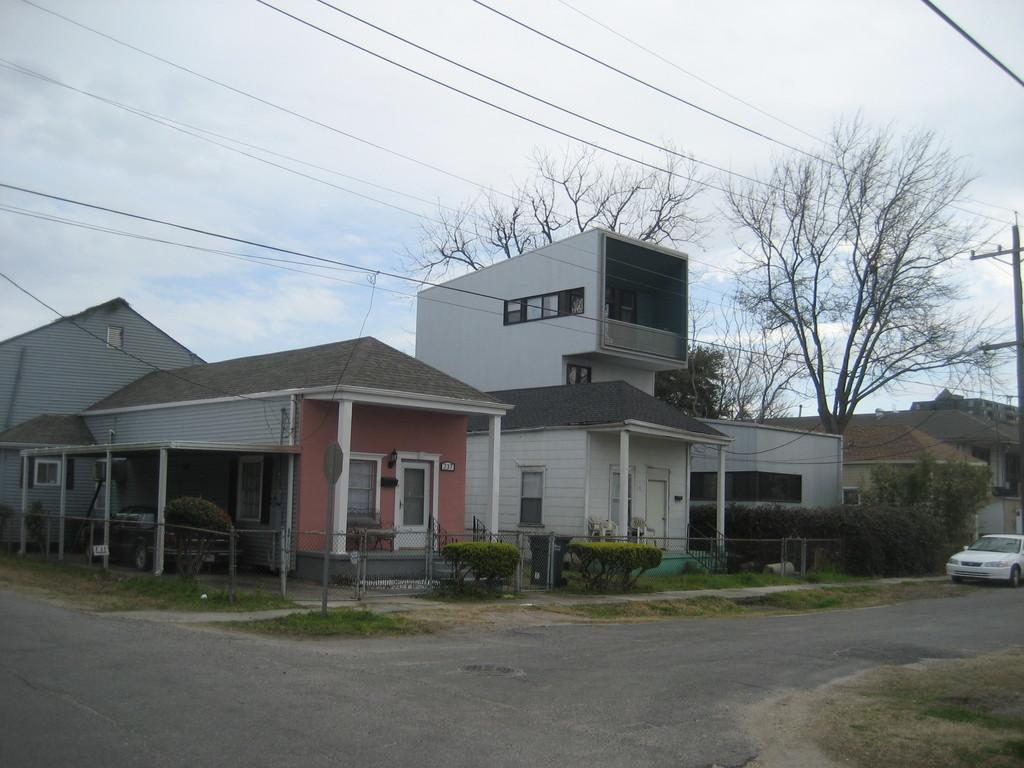What type of structures can be seen in the image? There are houses in the image. What type of vegetation is present in the image? There are shrubs and trees in the image. What type of barrier can be seen in the image? There is a fence in the image. What is parked in front of the house? There is a car in front of the house. What is located in front of the house, besides the car? There is a pole in front of the house. What else can be seen in the image, related to infrastructure? There are cables visible in the image. How many horses are galloping through the yard in the image? There are no horses present in the image. What type of crook is attempting to steal the car in the image? There is no crook or theft depicted in the image. 